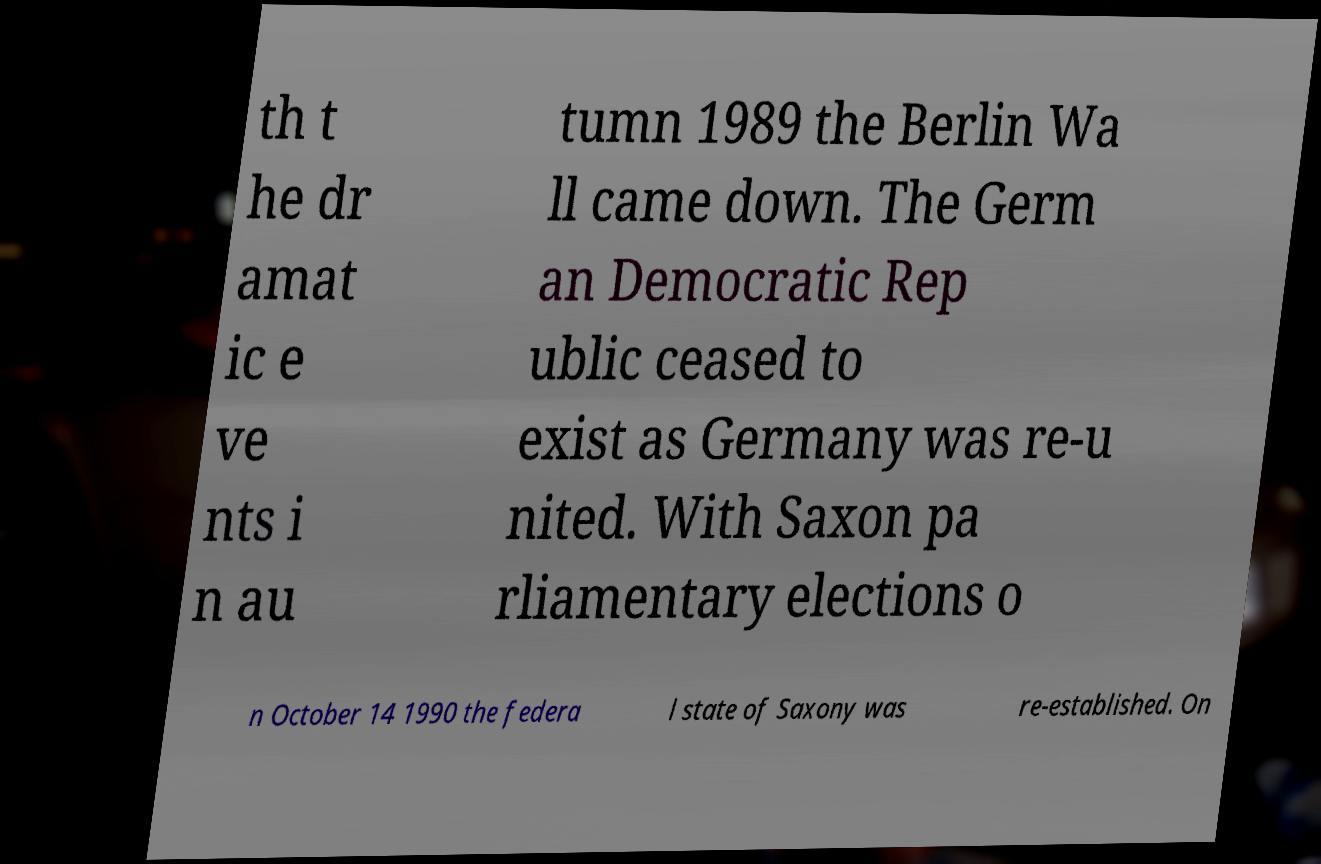For documentation purposes, I need the text within this image transcribed. Could you provide that? th t he dr amat ic e ve nts i n au tumn 1989 the Berlin Wa ll came down. The Germ an Democratic Rep ublic ceased to exist as Germany was re-u nited. With Saxon pa rliamentary elections o n October 14 1990 the federa l state of Saxony was re-established. On 